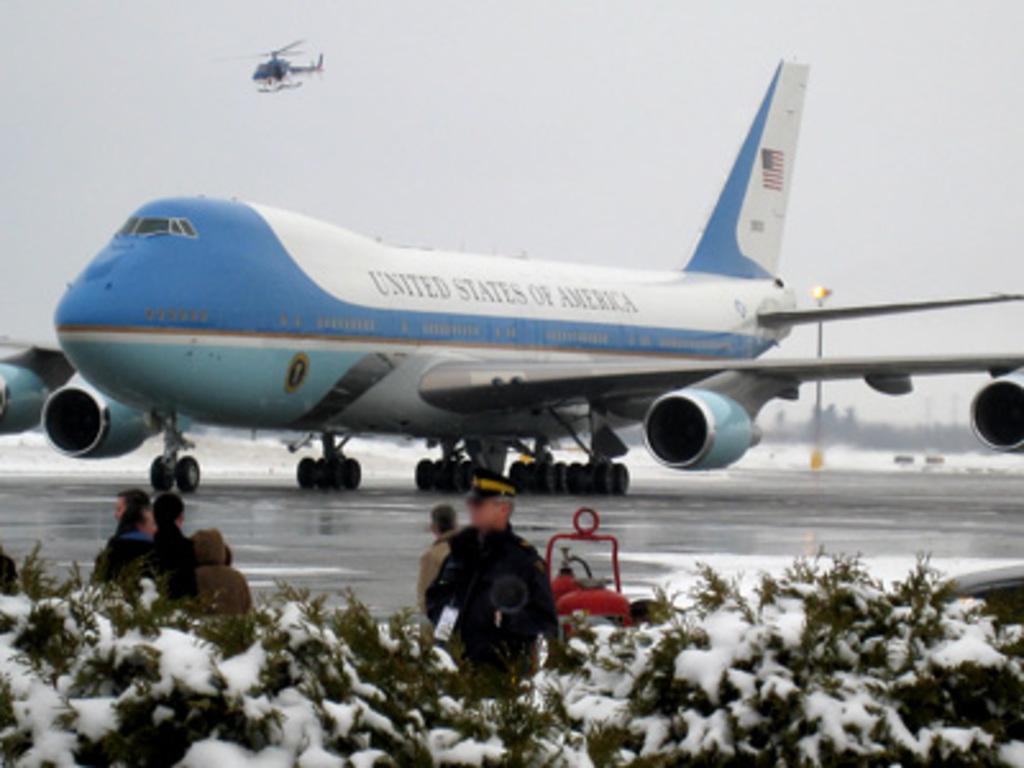What country is on the plane?
Provide a succinct answer. United states of america. 